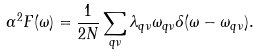<formula> <loc_0><loc_0><loc_500><loc_500>\alpha ^ { 2 } F ( \omega ) = \frac { 1 } { 2 N } \sum _ { { q } \nu } \lambda _ { { q } \nu } \omega _ { { q } \nu } \delta ( \omega - \omega _ { { q } \nu } ) .</formula> 